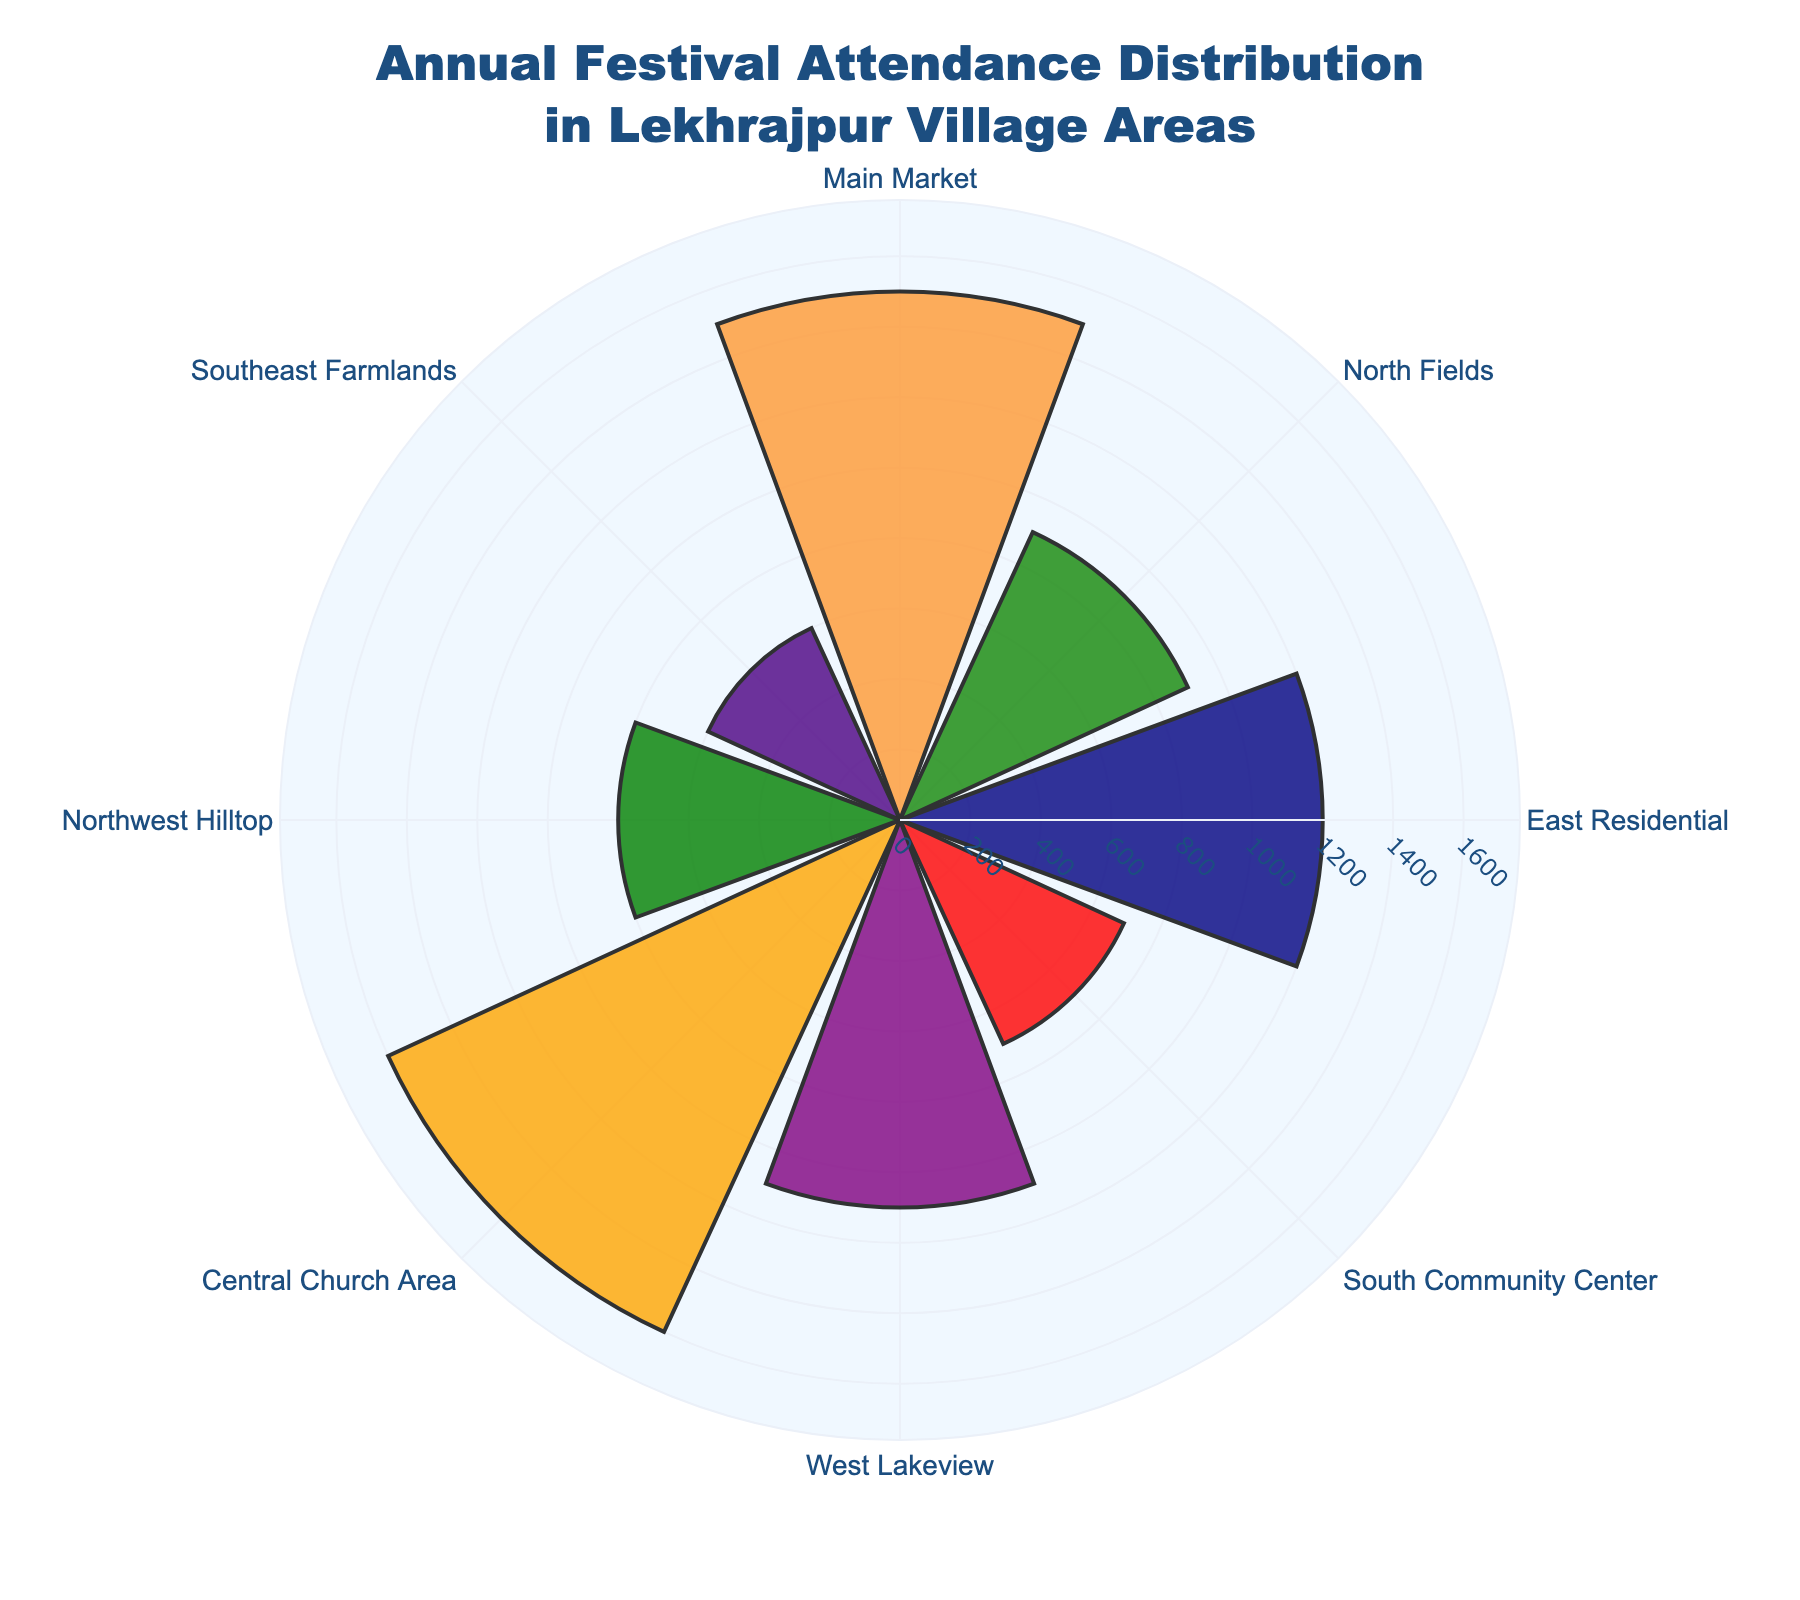What is the title of the figure? The title is displayed at the top of the figure. It typically provides a summary of what the figure is about.
Answer: Annual Festival Attendance Distribution in Lekhrajpur Village Areas What is the attendance in the Central Church Area? Look at the radial bar labeled as "Central Church Area" and read the corresponding length on the radial axis.
Answer: 1600 Which village area has the lowest festival attendance? Identify the shortest bar in the rose chart. The label associated with this bar represents the village area with the lowest attendance.
Answer: Southeast Farmlands Which village area has the highest festival attendance? Identify the longest bar in the rose chart. The label associated with this bar represents the village area with the highest attendance.
Answer: Central Church Area What is the difference in festival attendance between the Main Market and Southeast Farmlands? Find the attendance values for both Main Market and Southeast Farmlands, then subtract the smaller value from the larger one (1500 - 600).
Answer: 900 What is the total festival attendance for North Fields and West Lakeview combined? Find the attendance values for North Fields and West Lakeview, then add them together (900 + 1100).
Answer: 2000 Is the attendance at East Residential greater than that at West Lakeview? Compare the heights of the bars labeled "East Residential" and "West Lakeview". East Residential has 1200 and West Lakeview has 1100, so 1200 > 1100.
Answer: Yes Which area has a higher attendance, South Community Center or Northwest Hilltop? Compare the lengths of the bars for South Community Center (700) and Northwest Hilltop (800). 800 > 700.
Answer: Northwest Hilltop What is the average festival attendance across all village areas? Add the attendance values for all areas (1500 + 900 + 1200 + 700 + 1100 + 1600 + 800 + 600) = 8400, then divide by the number of areas, which is 8. So, 8400 / 8 = 1050.
Answer: 1050 How much more is the attendance in the Central Church Area compared to the Northwest Hilltop? Subtract the attendance of Northwest Hilltop (800) from Central Church Area (1600). 1600 - 800 = 800.
Answer: 800 